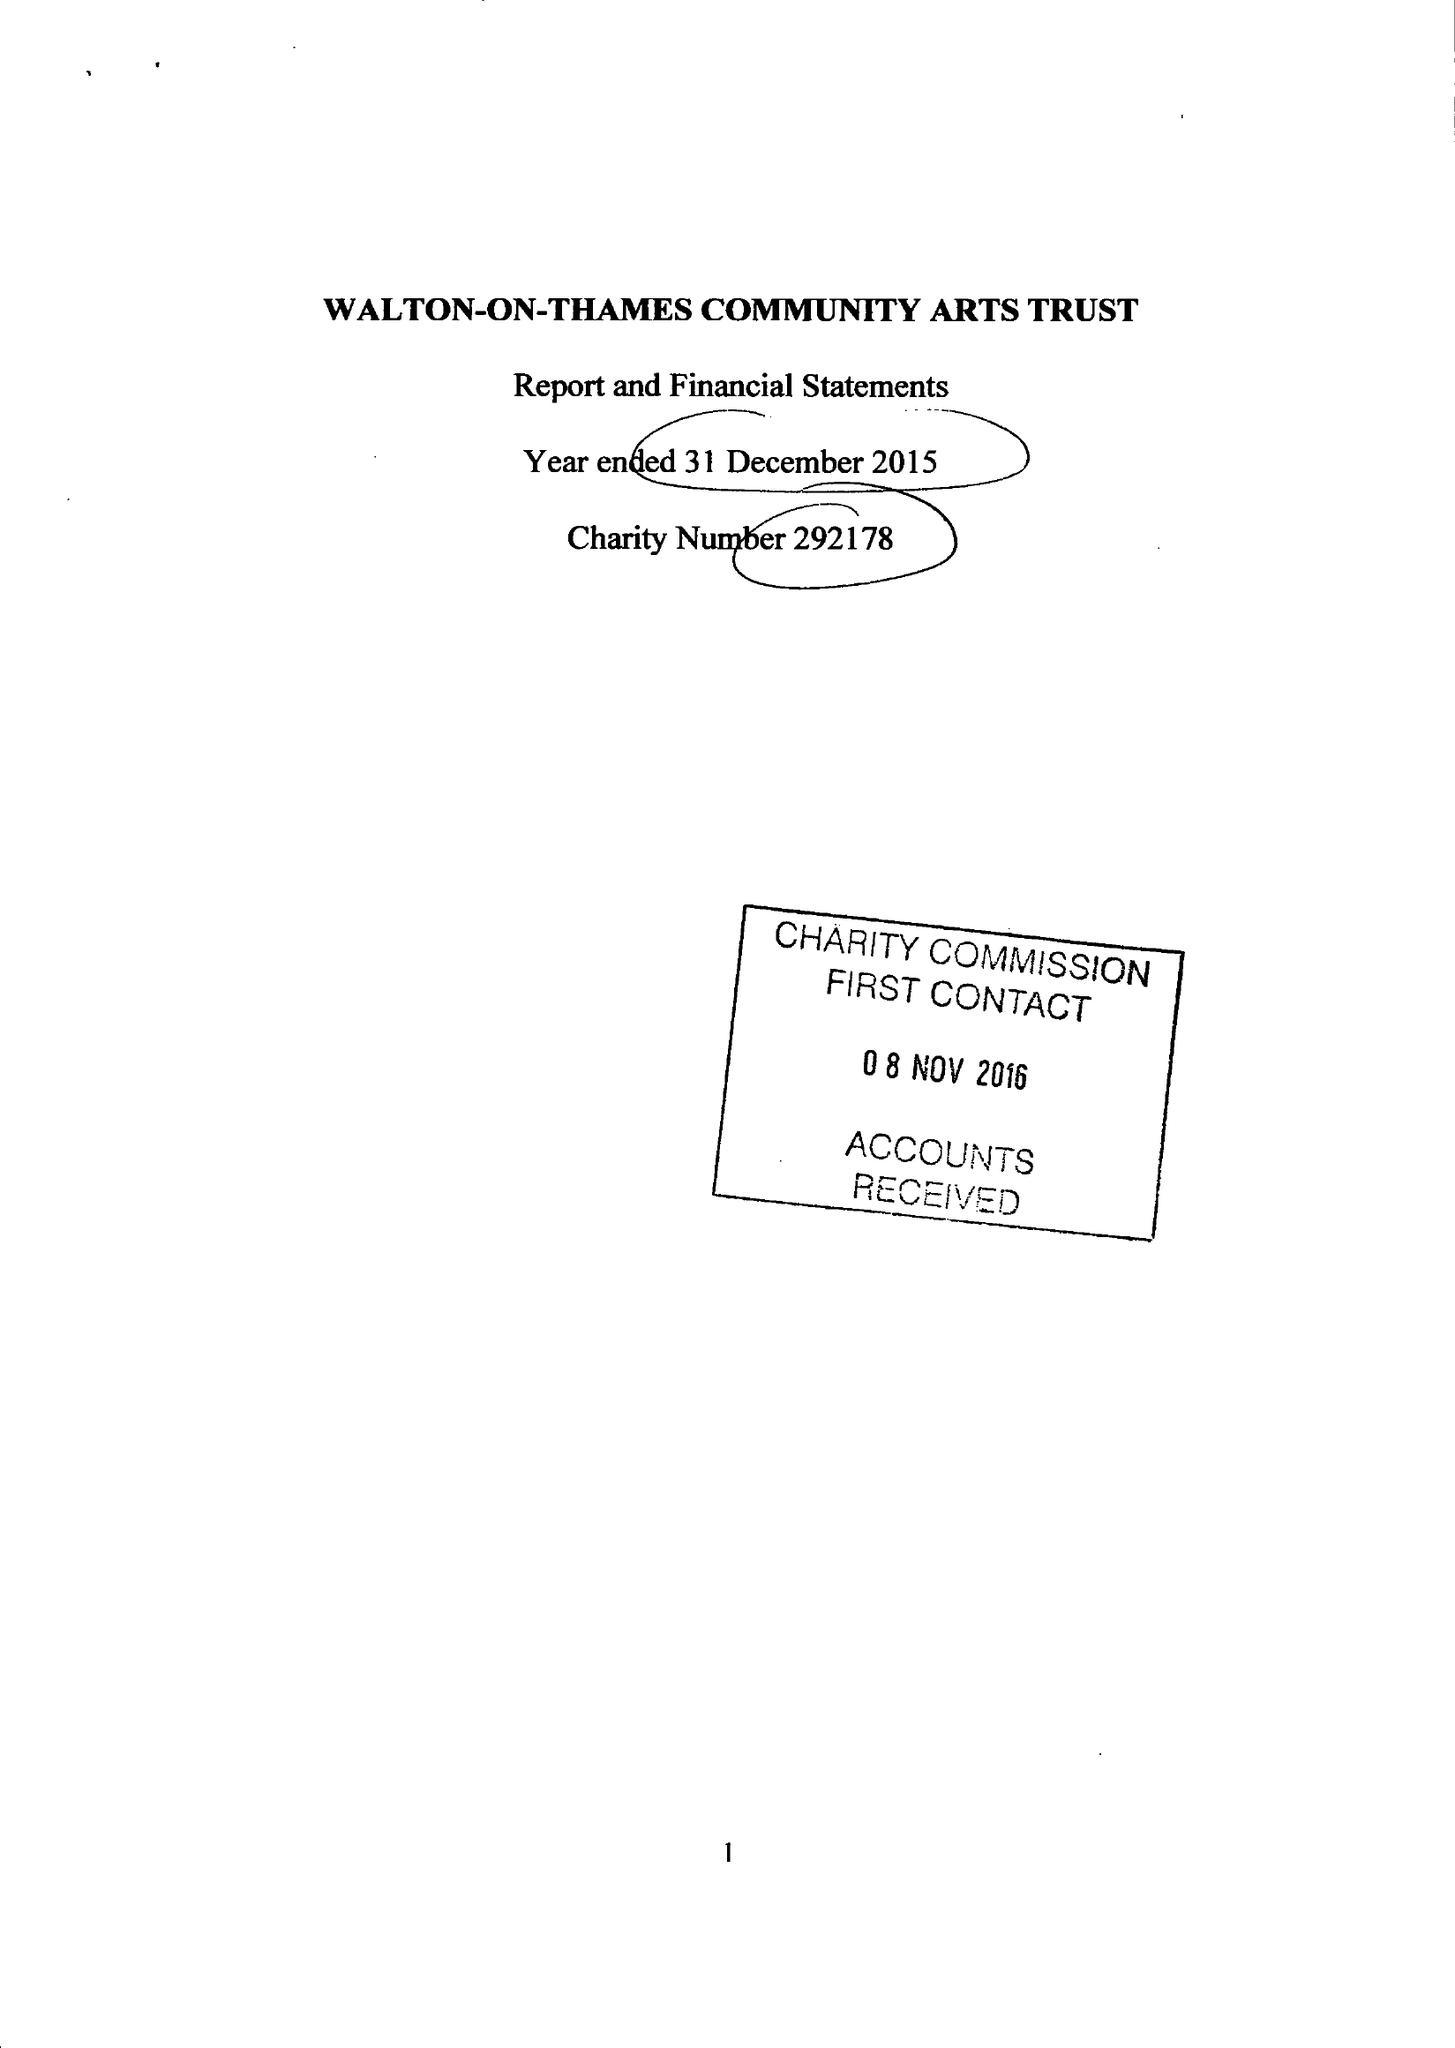What is the value for the address__post_town?
Answer the question using a single word or phrase. WALTON-ON-THAMES 